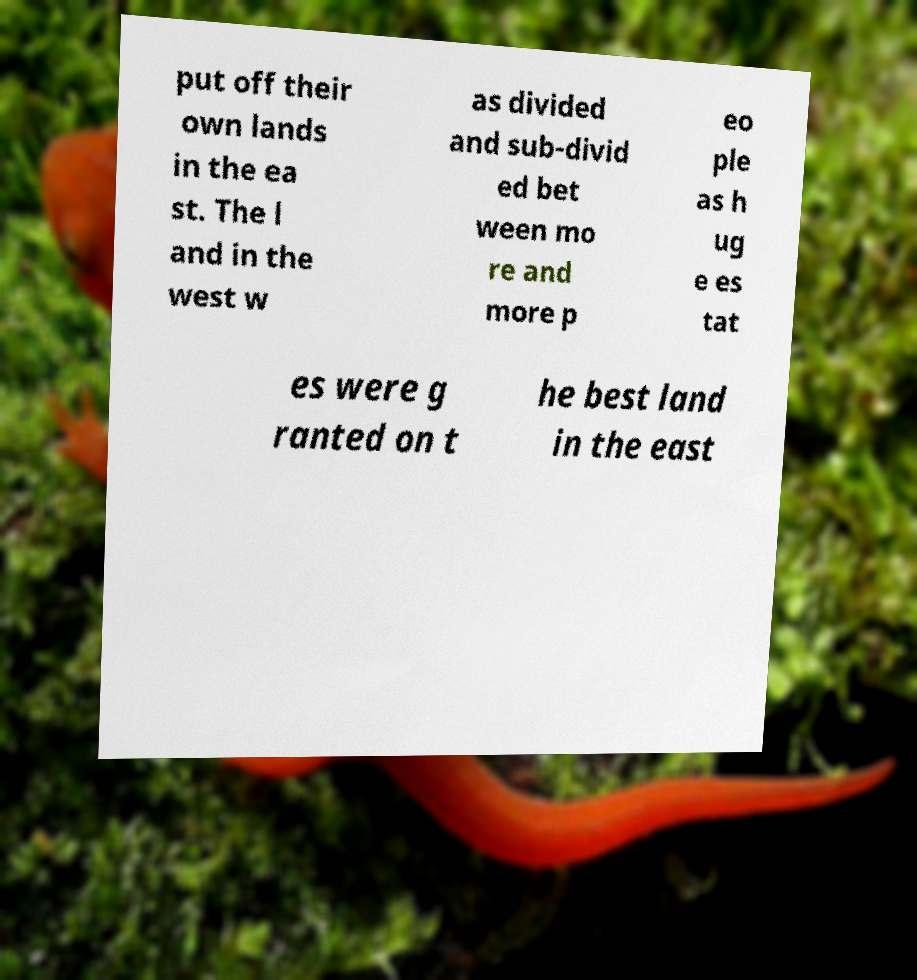For documentation purposes, I need the text within this image transcribed. Could you provide that? put off their own lands in the ea st. The l and in the west w as divided and sub-divid ed bet ween mo re and more p eo ple as h ug e es tat es were g ranted on t he best land in the east 